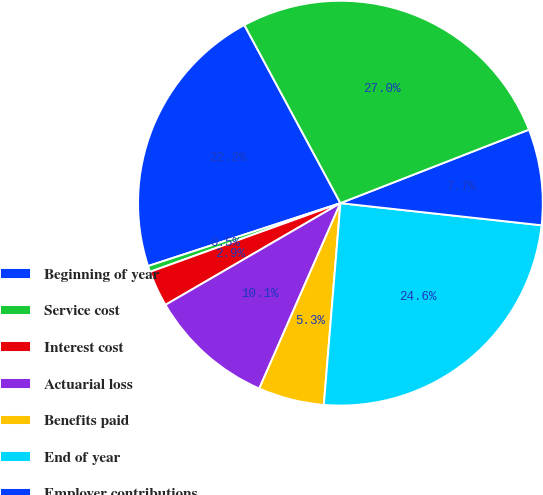Convert chart to OTSL. <chart><loc_0><loc_0><loc_500><loc_500><pie_chart><fcel>Beginning of year<fcel>Service cost<fcel>Interest cost<fcel>Actuarial loss<fcel>Benefits paid<fcel>End of year<fcel>Employer contributions<fcel>Funded status (unfunded)<nl><fcel>22.16%<fcel>0.48%<fcel>2.87%<fcel>10.05%<fcel>5.26%<fcel>24.56%<fcel>7.66%<fcel>26.95%<nl></chart> 